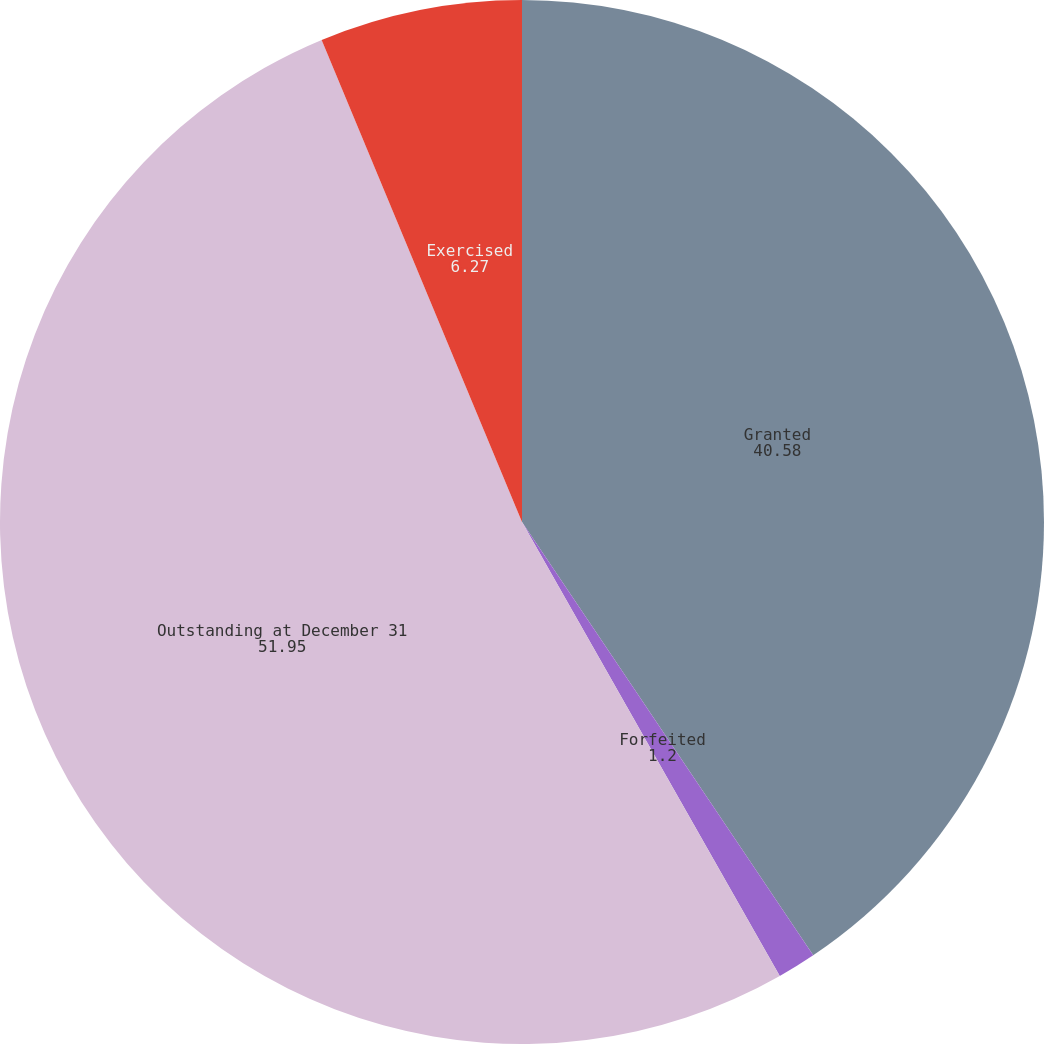Convert chart. <chart><loc_0><loc_0><loc_500><loc_500><pie_chart><fcel>Granted<fcel>Forfeited<fcel>Outstanding at December 31<fcel>Exercised<nl><fcel>40.58%<fcel>1.2%<fcel>51.95%<fcel>6.27%<nl></chart> 